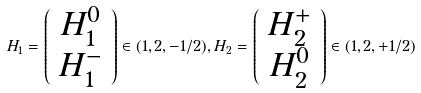<formula> <loc_0><loc_0><loc_500><loc_500>H _ { 1 } = \left ( \begin{array} { c } H ^ { 0 } _ { 1 } \\ H ^ { - } _ { 1 } \end{array} \right ) \in ( 1 , 2 , - 1 / 2 ) , H _ { 2 } = \left ( \begin{array} { c } H ^ { + } _ { 2 } \\ H ^ { 0 } _ { 2 } \end{array} \right ) \in ( 1 , 2 , + 1 / 2 )</formula> 